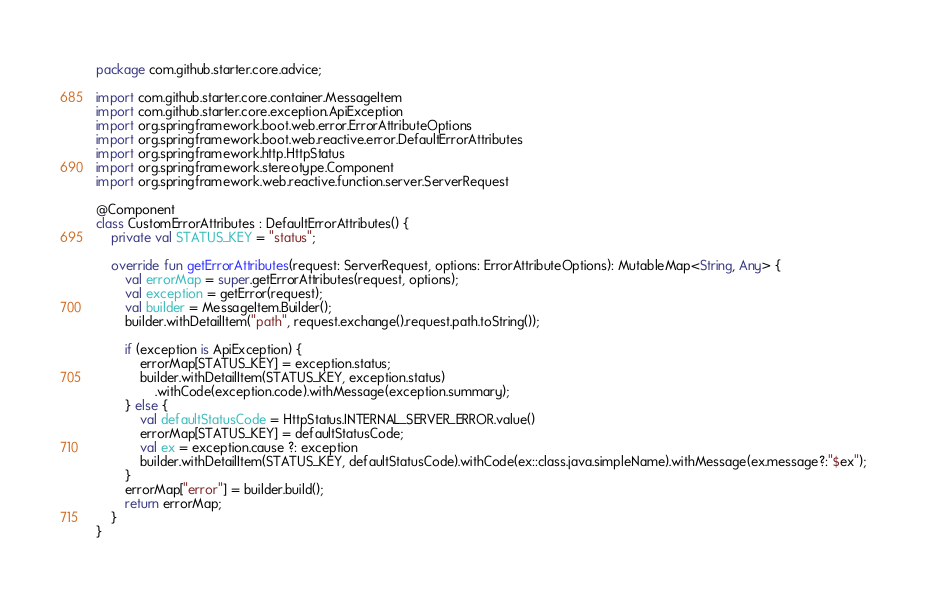<code> <loc_0><loc_0><loc_500><loc_500><_Kotlin_>package com.github.starter.core.advice;

import com.github.starter.core.container.MessageItem
import com.github.starter.core.exception.ApiException
import org.springframework.boot.web.error.ErrorAttributeOptions
import org.springframework.boot.web.reactive.error.DefaultErrorAttributes
import org.springframework.http.HttpStatus
import org.springframework.stereotype.Component
import org.springframework.web.reactive.function.server.ServerRequest

@Component
class CustomErrorAttributes : DefaultErrorAttributes() {
    private val STATUS_KEY = "status";

    override fun getErrorAttributes(request: ServerRequest, options: ErrorAttributeOptions): MutableMap<String, Any> {
        val errorMap = super.getErrorAttributes(request, options);
        val exception = getError(request);
        val builder = MessageItem.Builder();
        builder.withDetailItem("path", request.exchange().request.path.toString());

        if (exception is ApiException) {
            errorMap[STATUS_KEY] = exception.status;
            builder.withDetailItem(STATUS_KEY, exception.status)
                .withCode(exception.code).withMessage(exception.summary);
        } else {
            val defaultStatusCode = HttpStatus.INTERNAL_SERVER_ERROR.value()
            errorMap[STATUS_KEY] = defaultStatusCode;
            val ex = exception.cause ?: exception
            builder.withDetailItem(STATUS_KEY, defaultStatusCode).withCode(ex::class.java.simpleName).withMessage(ex.message?:"$ex");
        }
        errorMap["error"] = builder.build();
        return errorMap;
    }
}
</code> 